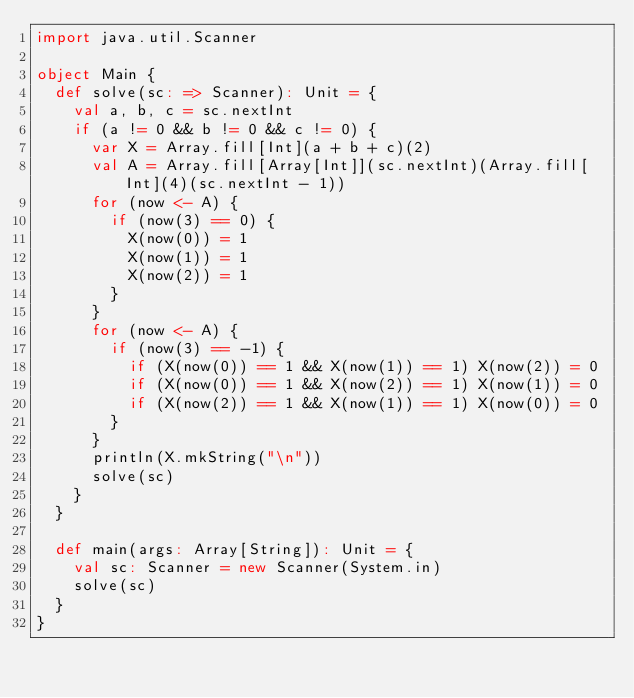Convert code to text. <code><loc_0><loc_0><loc_500><loc_500><_Scala_>import java.util.Scanner

object Main {
  def solve(sc: => Scanner): Unit = {
    val a, b, c = sc.nextInt
    if (a != 0 && b != 0 && c != 0) {
      var X = Array.fill[Int](a + b + c)(2)
      val A = Array.fill[Array[Int]](sc.nextInt)(Array.fill[Int](4)(sc.nextInt - 1))
      for (now <- A) {
        if (now(3) == 0) {
          X(now(0)) = 1
          X(now(1)) = 1
          X(now(2)) = 1
        }
      }
      for (now <- A) {
        if (now(3) == -1) {
          if (X(now(0)) == 1 && X(now(1)) == 1) X(now(2)) = 0
          if (X(now(0)) == 1 && X(now(2)) == 1) X(now(1)) = 0
          if (X(now(2)) == 1 && X(now(1)) == 1) X(now(0)) = 0
        }
      }
      println(X.mkString("\n"))
      solve(sc)
    }
  }

  def main(args: Array[String]): Unit = {
    val sc: Scanner = new Scanner(System.in)
    solve(sc)
  }
}</code> 